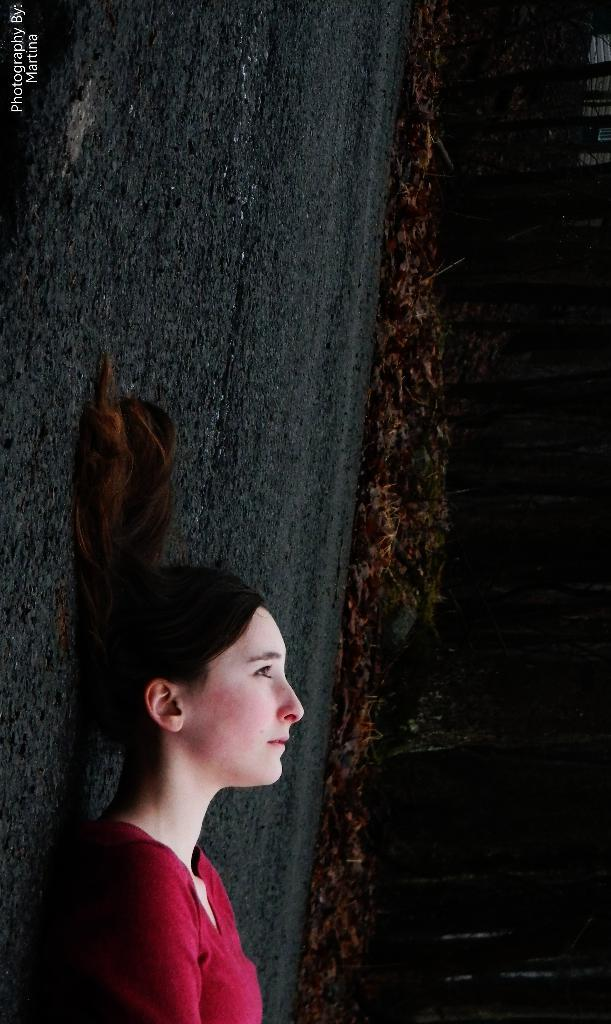Who is present in the image? There is a woman in the image. What is the woman wearing? The woman is wearing a red t-shirt. What is the woman's position in the image? The woman is lying on the road. What can be seen in the top left corner of the image? There is a watermark in the top left corner of the image. What type of vegetation is visible in the background of the image? There are plants in the background of the image. How would you describe the color of the background in the image? The background of the image is dark in color. What type of nut is the woman cracking in the image? There is no nut present in the image; the woman is lying on the road and not performing any actions involving nuts. 